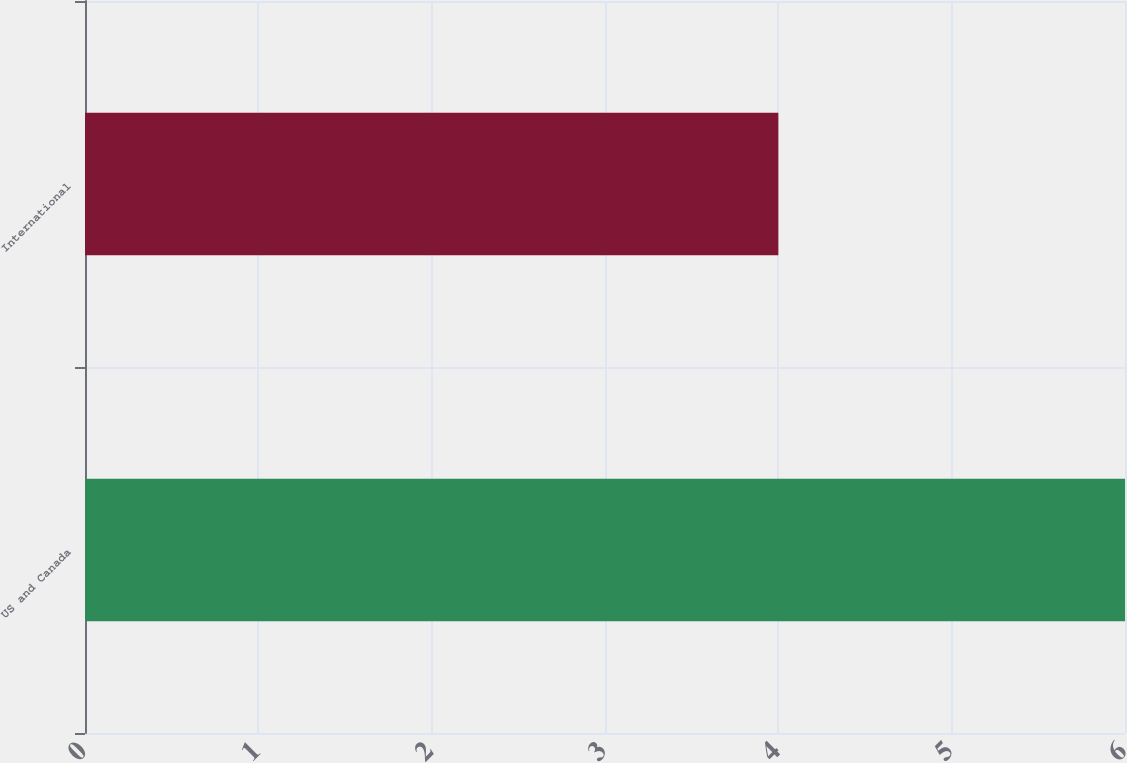Convert chart to OTSL. <chart><loc_0><loc_0><loc_500><loc_500><bar_chart><fcel>US and Canada<fcel>International<nl><fcel>6<fcel>4<nl></chart> 